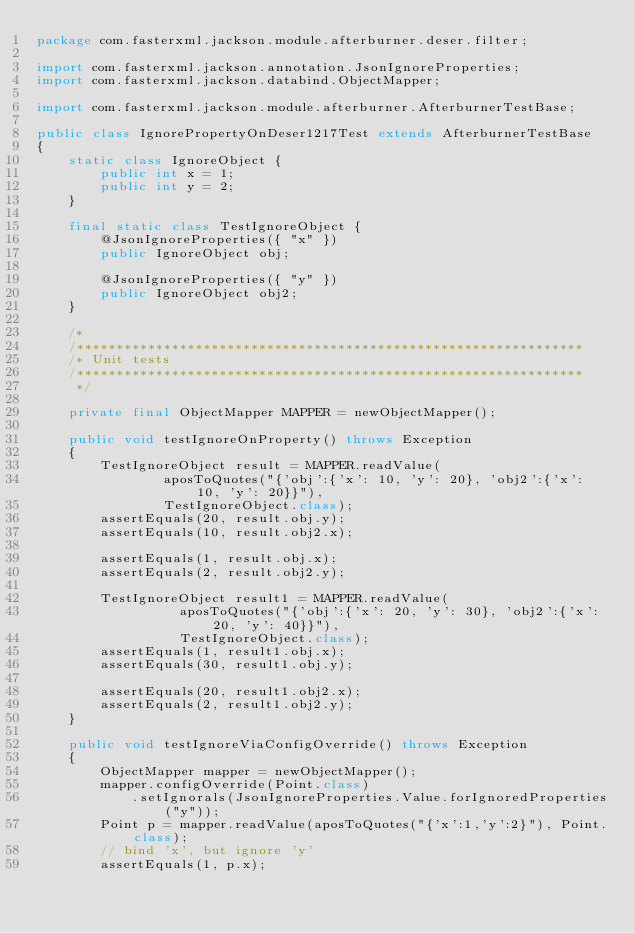Convert code to text. <code><loc_0><loc_0><loc_500><loc_500><_Java_>package com.fasterxml.jackson.module.afterburner.deser.filter;

import com.fasterxml.jackson.annotation.JsonIgnoreProperties;
import com.fasterxml.jackson.databind.ObjectMapper;

import com.fasterxml.jackson.module.afterburner.AfterburnerTestBase;

public class IgnorePropertyOnDeser1217Test extends AfterburnerTestBase
{
    static class IgnoreObject {
        public int x = 1;
        public int y = 2;
    }

    final static class TestIgnoreObject {
        @JsonIgnoreProperties({ "x" })
        public IgnoreObject obj;

        @JsonIgnoreProperties({ "y" })
        public IgnoreObject obj2;
    }

    /*
    /****************************************************************
    /* Unit tests
    /****************************************************************
     */

    private final ObjectMapper MAPPER = newObjectMapper();

    public void testIgnoreOnProperty() throws Exception
    {
        TestIgnoreObject result = MAPPER.readValue(
                aposToQuotes("{'obj':{'x': 10, 'y': 20}, 'obj2':{'x': 10, 'y': 20}}"),
                TestIgnoreObject.class);
        assertEquals(20, result.obj.y);
        assertEquals(10, result.obj2.x);

        assertEquals(1, result.obj.x);
        assertEquals(2, result.obj2.y);
        
        TestIgnoreObject result1 = MAPPER.readValue(
                  aposToQuotes("{'obj':{'x': 20, 'y': 30}, 'obj2':{'x': 20, 'y': 40}}"),
                  TestIgnoreObject.class);
        assertEquals(1, result1.obj.x);
        assertEquals(30, result1.obj.y);
       
        assertEquals(20, result1.obj2.x);
        assertEquals(2, result1.obj2.y);
    }

    public void testIgnoreViaConfigOverride() throws Exception
    {
        ObjectMapper mapper = newObjectMapper();
        mapper.configOverride(Point.class)
            .setIgnorals(JsonIgnoreProperties.Value.forIgnoredProperties("y"));
        Point p = mapper.readValue(aposToQuotes("{'x':1,'y':2}"), Point.class);
        // bind 'x', but ignore 'y'
        assertEquals(1, p.x);</code> 